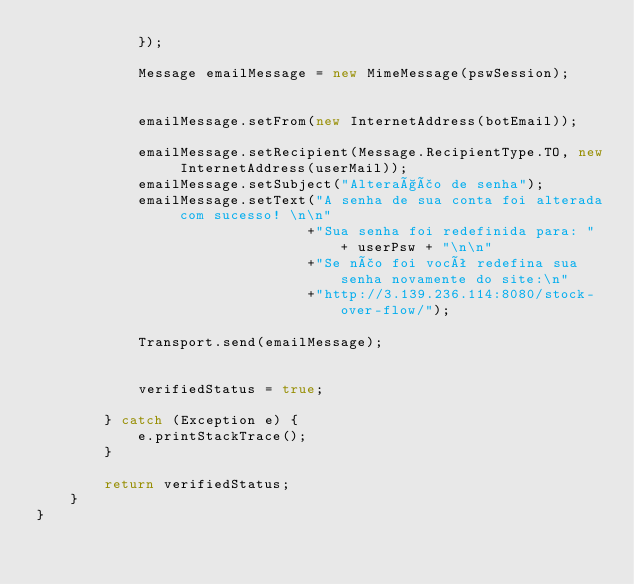Convert code to text. <code><loc_0><loc_0><loc_500><loc_500><_Java_>            });

            Message emailMessage = new MimeMessage(pswSession);

 
            emailMessage.setFrom(new InternetAddress(botEmail));

            emailMessage.setRecipient(Message.RecipientType.TO, new InternetAddress(userMail));
            emailMessage.setSubject("Alteração de senha");
            emailMessage.setText("A senha de sua conta foi alterada com sucesso! \n\n"
                                +"Sua senha foi redefinida para: " + userPsw + "\n\n"
                                +"Se não foi você redefina sua senha novamente do site:\n"
                                +"http://3.139.236.114:8080/stock-over-flow/");
            
            Transport.send(emailMessage);
            
            
            verifiedStatus = true;
            
        } catch (Exception e) {
            e.printStackTrace();
        }

        return verifiedStatus;
    }
}</code> 